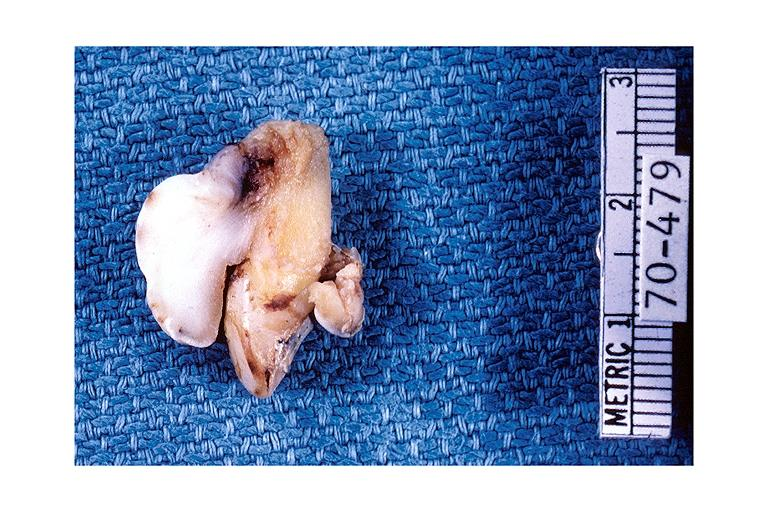what does this image show?
Answer the question using a single word or phrase. Periodontal fibroma 